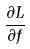Convert formula to latex. <formula><loc_0><loc_0><loc_500><loc_500>\frac { \partial L } { \partial f }</formula> 